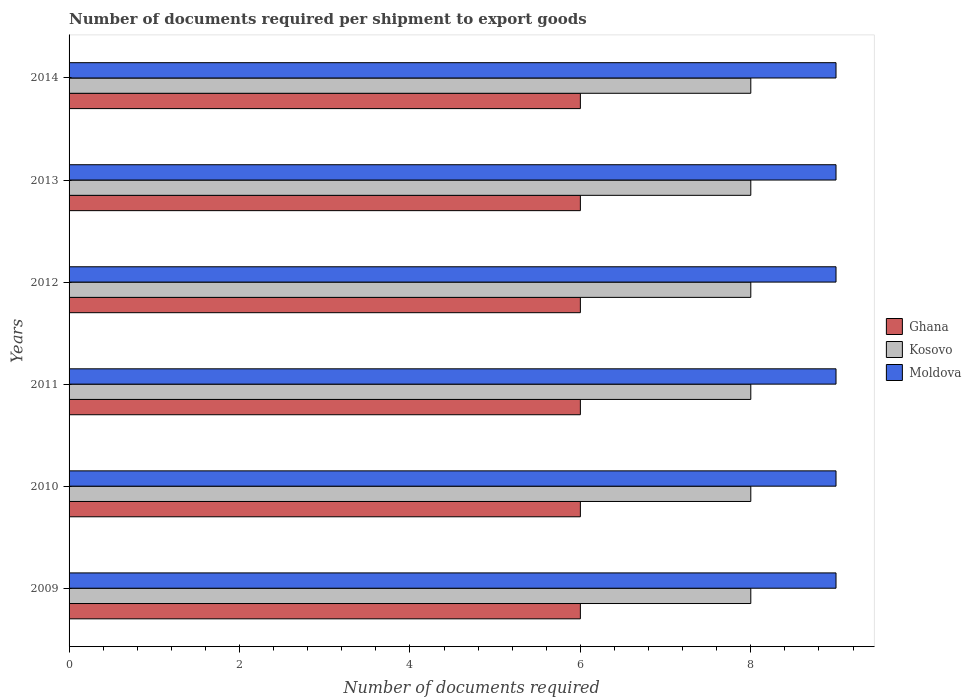How many groups of bars are there?
Offer a very short reply. 6. Are the number of bars on each tick of the Y-axis equal?
Give a very brief answer. Yes. What is the label of the 6th group of bars from the top?
Your response must be concise. 2009. In how many cases, is the number of bars for a given year not equal to the number of legend labels?
Your answer should be compact. 0. What is the number of documents required per shipment to export goods in Kosovo in 2011?
Make the answer very short. 8. Across all years, what is the minimum number of documents required per shipment to export goods in Kosovo?
Keep it short and to the point. 8. In which year was the number of documents required per shipment to export goods in Kosovo minimum?
Give a very brief answer. 2009. What is the total number of documents required per shipment to export goods in Kosovo in the graph?
Keep it short and to the point. 48. What is the difference between the number of documents required per shipment to export goods in Ghana in 2010 and that in 2011?
Make the answer very short. 0. What is the difference between the number of documents required per shipment to export goods in Kosovo in 2011 and the number of documents required per shipment to export goods in Moldova in 2014?
Offer a very short reply. -1. In the year 2012, what is the difference between the number of documents required per shipment to export goods in Ghana and number of documents required per shipment to export goods in Moldova?
Keep it short and to the point. -3. What does the 1st bar from the top in 2013 represents?
Offer a very short reply. Moldova. What does the 2nd bar from the bottom in 2010 represents?
Give a very brief answer. Kosovo. What is the difference between two consecutive major ticks on the X-axis?
Provide a short and direct response. 2. How many legend labels are there?
Your answer should be very brief. 3. What is the title of the graph?
Your answer should be compact. Number of documents required per shipment to export goods. Does "Iraq" appear as one of the legend labels in the graph?
Ensure brevity in your answer.  No. What is the label or title of the X-axis?
Provide a short and direct response. Number of documents required. What is the label or title of the Y-axis?
Make the answer very short. Years. What is the Number of documents required in Kosovo in 2009?
Your response must be concise. 8. What is the Number of documents required in Moldova in 2009?
Ensure brevity in your answer.  9. What is the Number of documents required in Ghana in 2011?
Make the answer very short. 6. What is the Number of documents required of Kosovo in 2011?
Offer a terse response. 8. What is the Number of documents required of Moldova in 2011?
Offer a very short reply. 9. What is the Number of documents required in Ghana in 2012?
Give a very brief answer. 6. What is the Number of documents required of Kosovo in 2012?
Offer a terse response. 8. What is the Number of documents required of Kosovo in 2013?
Provide a short and direct response. 8. What is the Number of documents required in Ghana in 2014?
Your answer should be compact. 6. Across all years, what is the maximum Number of documents required in Ghana?
Ensure brevity in your answer.  6. Across all years, what is the maximum Number of documents required in Kosovo?
Provide a succinct answer. 8. Across all years, what is the minimum Number of documents required of Moldova?
Give a very brief answer. 9. What is the total Number of documents required in Moldova in the graph?
Offer a very short reply. 54. What is the difference between the Number of documents required of Moldova in 2009 and that in 2010?
Give a very brief answer. 0. What is the difference between the Number of documents required in Ghana in 2009 and that in 2011?
Provide a short and direct response. 0. What is the difference between the Number of documents required in Kosovo in 2009 and that in 2011?
Give a very brief answer. 0. What is the difference between the Number of documents required of Kosovo in 2009 and that in 2012?
Provide a succinct answer. 0. What is the difference between the Number of documents required in Kosovo in 2009 and that in 2013?
Give a very brief answer. 0. What is the difference between the Number of documents required of Moldova in 2009 and that in 2013?
Give a very brief answer. 0. What is the difference between the Number of documents required of Kosovo in 2009 and that in 2014?
Make the answer very short. 0. What is the difference between the Number of documents required of Moldova in 2009 and that in 2014?
Provide a succinct answer. 0. What is the difference between the Number of documents required in Kosovo in 2010 and that in 2011?
Give a very brief answer. 0. What is the difference between the Number of documents required in Ghana in 2010 and that in 2012?
Offer a very short reply. 0. What is the difference between the Number of documents required in Kosovo in 2010 and that in 2013?
Keep it short and to the point. 0. What is the difference between the Number of documents required of Moldova in 2010 and that in 2013?
Offer a very short reply. 0. What is the difference between the Number of documents required of Moldova in 2010 and that in 2014?
Make the answer very short. 0. What is the difference between the Number of documents required of Ghana in 2011 and that in 2012?
Provide a succinct answer. 0. What is the difference between the Number of documents required in Moldova in 2011 and that in 2012?
Ensure brevity in your answer.  0. What is the difference between the Number of documents required of Moldova in 2011 and that in 2013?
Make the answer very short. 0. What is the difference between the Number of documents required in Kosovo in 2012 and that in 2013?
Give a very brief answer. 0. What is the difference between the Number of documents required in Ghana in 2012 and that in 2014?
Offer a terse response. 0. What is the difference between the Number of documents required of Moldova in 2012 and that in 2014?
Your answer should be very brief. 0. What is the difference between the Number of documents required of Ghana in 2013 and that in 2014?
Your answer should be very brief. 0. What is the difference between the Number of documents required in Kosovo in 2013 and that in 2014?
Your answer should be compact. 0. What is the difference between the Number of documents required in Ghana in 2009 and the Number of documents required in Kosovo in 2010?
Provide a short and direct response. -2. What is the difference between the Number of documents required in Ghana in 2009 and the Number of documents required in Moldova in 2010?
Offer a terse response. -3. What is the difference between the Number of documents required in Kosovo in 2009 and the Number of documents required in Moldova in 2010?
Provide a short and direct response. -1. What is the difference between the Number of documents required of Kosovo in 2009 and the Number of documents required of Moldova in 2011?
Your answer should be compact. -1. What is the difference between the Number of documents required in Ghana in 2009 and the Number of documents required in Kosovo in 2012?
Provide a succinct answer. -2. What is the difference between the Number of documents required of Ghana in 2009 and the Number of documents required of Moldova in 2012?
Give a very brief answer. -3. What is the difference between the Number of documents required in Ghana in 2009 and the Number of documents required in Kosovo in 2013?
Your answer should be very brief. -2. What is the difference between the Number of documents required of Ghana in 2009 and the Number of documents required of Moldova in 2013?
Your answer should be compact. -3. What is the difference between the Number of documents required of Kosovo in 2009 and the Number of documents required of Moldova in 2013?
Make the answer very short. -1. What is the difference between the Number of documents required in Ghana in 2009 and the Number of documents required in Moldova in 2014?
Your answer should be very brief. -3. What is the difference between the Number of documents required of Ghana in 2010 and the Number of documents required of Moldova in 2011?
Give a very brief answer. -3. What is the difference between the Number of documents required of Ghana in 2010 and the Number of documents required of Kosovo in 2012?
Ensure brevity in your answer.  -2. What is the difference between the Number of documents required of Ghana in 2010 and the Number of documents required of Moldova in 2012?
Your response must be concise. -3. What is the difference between the Number of documents required in Kosovo in 2010 and the Number of documents required in Moldova in 2012?
Give a very brief answer. -1. What is the difference between the Number of documents required of Ghana in 2010 and the Number of documents required of Kosovo in 2014?
Keep it short and to the point. -2. What is the difference between the Number of documents required in Ghana in 2010 and the Number of documents required in Moldova in 2014?
Make the answer very short. -3. What is the difference between the Number of documents required of Kosovo in 2011 and the Number of documents required of Moldova in 2013?
Make the answer very short. -1. What is the difference between the Number of documents required in Ghana in 2011 and the Number of documents required in Kosovo in 2014?
Make the answer very short. -2. What is the difference between the Number of documents required in Ghana in 2012 and the Number of documents required in Moldova in 2013?
Your response must be concise. -3. What is the difference between the Number of documents required in Kosovo in 2012 and the Number of documents required in Moldova in 2014?
Your response must be concise. -1. What is the difference between the Number of documents required in Ghana in 2013 and the Number of documents required in Kosovo in 2014?
Your response must be concise. -2. What is the difference between the Number of documents required of Ghana in 2013 and the Number of documents required of Moldova in 2014?
Keep it short and to the point. -3. What is the average Number of documents required of Kosovo per year?
Keep it short and to the point. 8. What is the average Number of documents required in Moldova per year?
Give a very brief answer. 9. In the year 2009, what is the difference between the Number of documents required of Ghana and Number of documents required of Kosovo?
Ensure brevity in your answer.  -2. In the year 2009, what is the difference between the Number of documents required in Ghana and Number of documents required in Moldova?
Offer a very short reply. -3. In the year 2009, what is the difference between the Number of documents required in Kosovo and Number of documents required in Moldova?
Your answer should be compact. -1. In the year 2010, what is the difference between the Number of documents required of Ghana and Number of documents required of Moldova?
Provide a succinct answer. -3. In the year 2011, what is the difference between the Number of documents required in Ghana and Number of documents required in Kosovo?
Your response must be concise. -2. In the year 2013, what is the difference between the Number of documents required in Ghana and Number of documents required in Moldova?
Offer a terse response. -3. In the year 2013, what is the difference between the Number of documents required of Kosovo and Number of documents required of Moldova?
Provide a short and direct response. -1. In the year 2014, what is the difference between the Number of documents required of Ghana and Number of documents required of Kosovo?
Ensure brevity in your answer.  -2. In the year 2014, what is the difference between the Number of documents required in Kosovo and Number of documents required in Moldova?
Your answer should be compact. -1. What is the ratio of the Number of documents required in Kosovo in 2009 to that in 2010?
Make the answer very short. 1. What is the ratio of the Number of documents required of Moldova in 2009 to that in 2010?
Ensure brevity in your answer.  1. What is the ratio of the Number of documents required in Ghana in 2009 to that in 2011?
Give a very brief answer. 1. What is the ratio of the Number of documents required in Moldova in 2009 to that in 2011?
Ensure brevity in your answer.  1. What is the ratio of the Number of documents required in Ghana in 2009 to that in 2012?
Offer a terse response. 1. What is the ratio of the Number of documents required in Kosovo in 2009 to that in 2012?
Offer a very short reply. 1. What is the ratio of the Number of documents required of Ghana in 2009 to that in 2013?
Provide a succinct answer. 1. What is the ratio of the Number of documents required of Kosovo in 2009 to that in 2013?
Ensure brevity in your answer.  1. What is the ratio of the Number of documents required in Moldova in 2009 to that in 2013?
Your answer should be compact. 1. What is the ratio of the Number of documents required in Ghana in 2009 to that in 2014?
Your answer should be very brief. 1. What is the ratio of the Number of documents required of Kosovo in 2010 to that in 2011?
Ensure brevity in your answer.  1. What is the ratio of the Number of documents required of Moldova in 2010 to that in 2011?
Offer a very short reply. 1. What is the ratio of the Number of documents required in Kosovo in 2010 to that in 2012?
Offer a terse response. 1. What is the ratio of the Number of documents required in Moldova in 2010 to that in 2012?
Your response must be concise. 1. What is the ratio of the Number of documents required in Ghana in 2010 to that in 2013?
Your answer should be very brief. 1. What is the ratio of the Number of documents required in Kosovo in 2010 to that in 2014?
Your answer should be compact. 1. What is the ratio of the Number of documents required of Kosovo in 2011 to that in 2012?
Your answer should be compact. 1. What is the ratio of the Number of documents required of Ghana in 2012 to that in 2013?
Your answer should be compact. 1. What is the ratio of the Number of documents required of Moldova in 2012 to that in 2013?
Ensure brevity in your answer.  1. What is the ratio of the Number of documents required of Moldova in 2012 to that in 2014?
Offer a very short reply. 1. What is the ratio of the Number of documents required in Ghana in 2013 to that in 2014?
Your response must be concise. 1. What is the ratio of the Number of documents required of Kosovo in 2013 to that in 2014?
Your answer should be compact. 1. What is the difference between the highest and the second highest Number of documents required of Ghana?
Give a very brief answer. 0. What is the difference between the highest and the second highest Number of documents required in Moldova?
Your response must be concise. 0. 